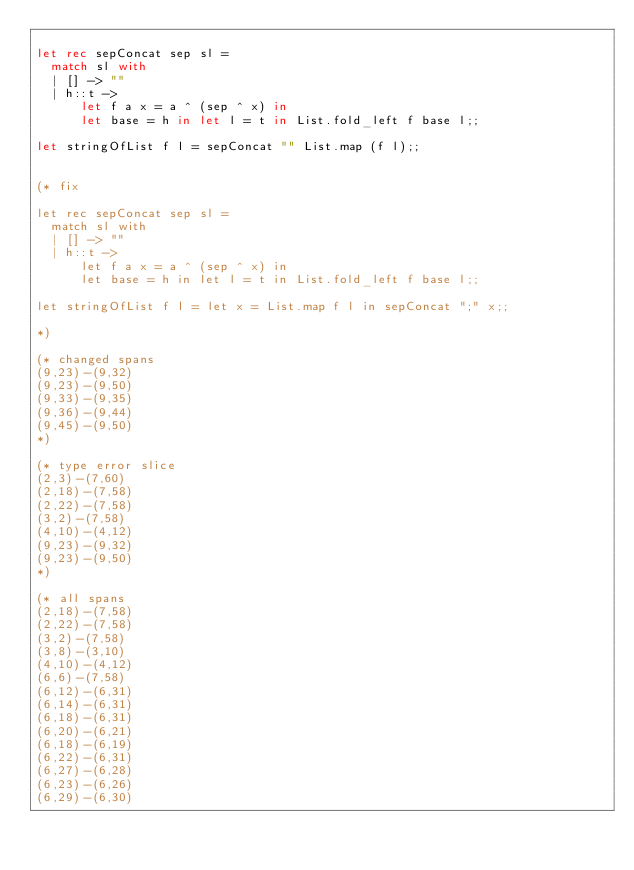Convert code to text. <code><loc_0><loc_0><loc_500><loc_500><_OCaml_>
let rec sepConcat sep sl =
  match sl with
  | [] -> ""
  | h::t ->
      let f a x = a ^ (sep ^ x) in
      let base = h in let l = t in List.fold_left f base l;;

let stringOfList f l = sepConcat "" List.map (f l);;


(* fix

let rec sepConcat sep sl =
  match sl with
  | [] -> ""
  | h::t ->
      let f a x = a ^ (sep ^ x) in
      let base = h in let l = t in List.fold_left f base l;;

let stringOfList f l = let x = List.map f l in sepConcat ";" x;;

*)

(* changed spans
(9,23)-(9,32)
(9,23)-(9,50)
(9,33)-(9,35)
(9,36)-(9,44)
(9,45)-(9,50)
*)

(* type error slice
(2,3)-(7,60)
(2,18)-(7,58)
(2,22)-(7,58)
(3,2)-(7,58)
(4,10)-(4,12)
(9,23)-(9,32)
(9,23)-(9,50)
*)

(* all spans
(2,18)-(7,58)
(2,22)-(7,58)
(3,2)-(7,58)
(3,8)-(3,10)
(4,10)-(4,12)
(6,6)-(7,58)
(6,12)-(6,31)
(6,14)-(6,31)
(6,18)-(6,31)
(6,20)-(6,21)
(6,18)-(6,19)
(6,22)-(6,31)
(6,27)-(6,28)
(6,23)-(6,26)
(6,29)-(6,30)</code> 